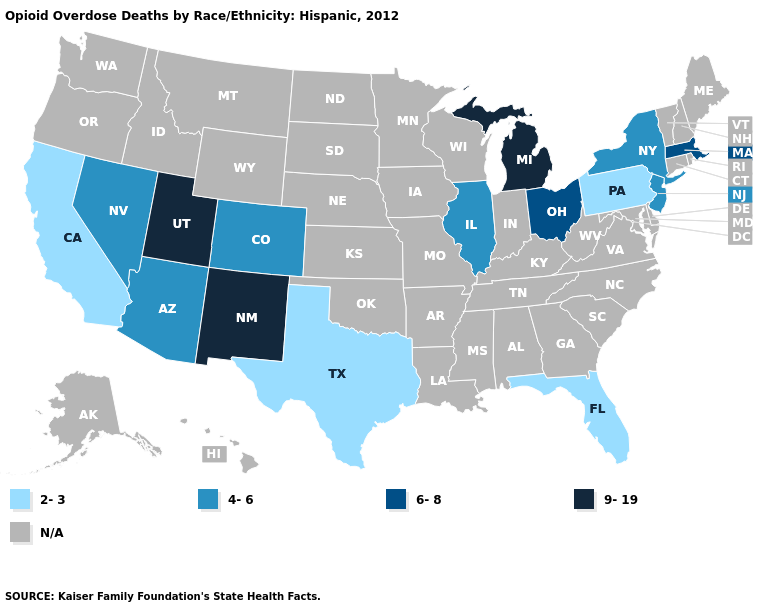What is the value of New Jersey?
Write a very short answer. 4-6. How many symbols are there in the legend?
Write a very short answer. 5. What is the value of North Carolina?
Write a very short answer. N/A. What is the lowest value in the South?
Write a very short answer. 2-3. Name the states that have a value in the range N/A?
Short answer required. Alabama, Alaska, Arkansas, Connecticut, Delaware, Georgia, Hawaii, Idaho, Indiana, Iowa, Kansas, Kentucky, Louisiana, Maine, Maryland, Minnesota, Mississippi, Missouri, Montana, Nebraska, New Hampshire, North Carolina, North Dakota, Oklahoma, Oregon, Rhode Island, South Carolina, South Dakota, Tennessee, Vermont, Virginia, Washington, West Virginia, Wisconsin, Wyoming. What is the value of South Dakota?
Write a very short answer. N/A. What is the lowest value in the USA?
Be succinct. 2-3. Is the legend a continuous bar?
Keep it brief. No. What is the lowest value in the USA?
Short answer required. 2-3. What is the value of Alaska?
Concise answer only. N/A. What is the highest value in the USA?
Answer briefly. 9-19. Among the states that border Idaho , which have the highest value?
Give a very brief answer. Utah. Which states hav the highest value in the South?
Answer briefly. Florida, Texas. Which states have the highest value in the USA?
Keep it brief. Michigan, New Mexico, Utah. 